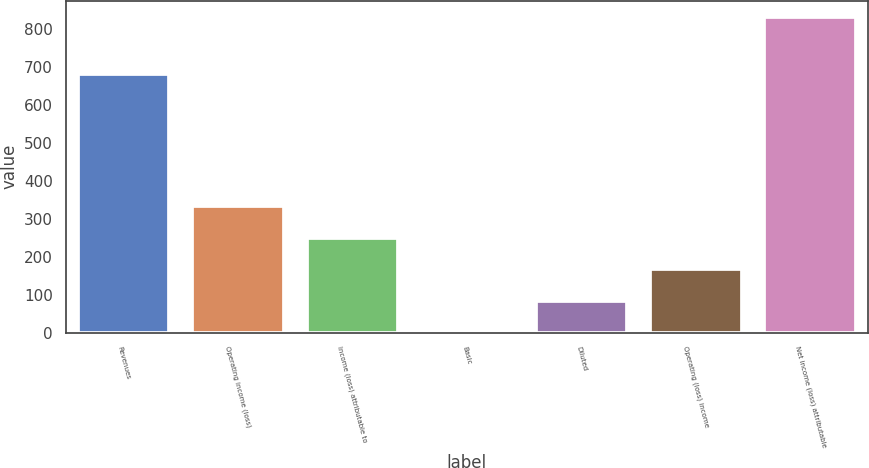Convert chart. <chart><loc_0><loc_0><loc_500><loc_500><bar_chart><fcel>Revenues<fcel>Operating income (loss)<fcel>Income (loss) attributable to<fcel>Basic<fcel>Diluted<fcel>Operating (loss) income<fcel>Net income (loss) attributable<nl><fcel>681<fcel>332.63<fcel>249.57<fcel>0.39<fcel>83.45<fcel>166.51<fcel>831<nl></chart> 